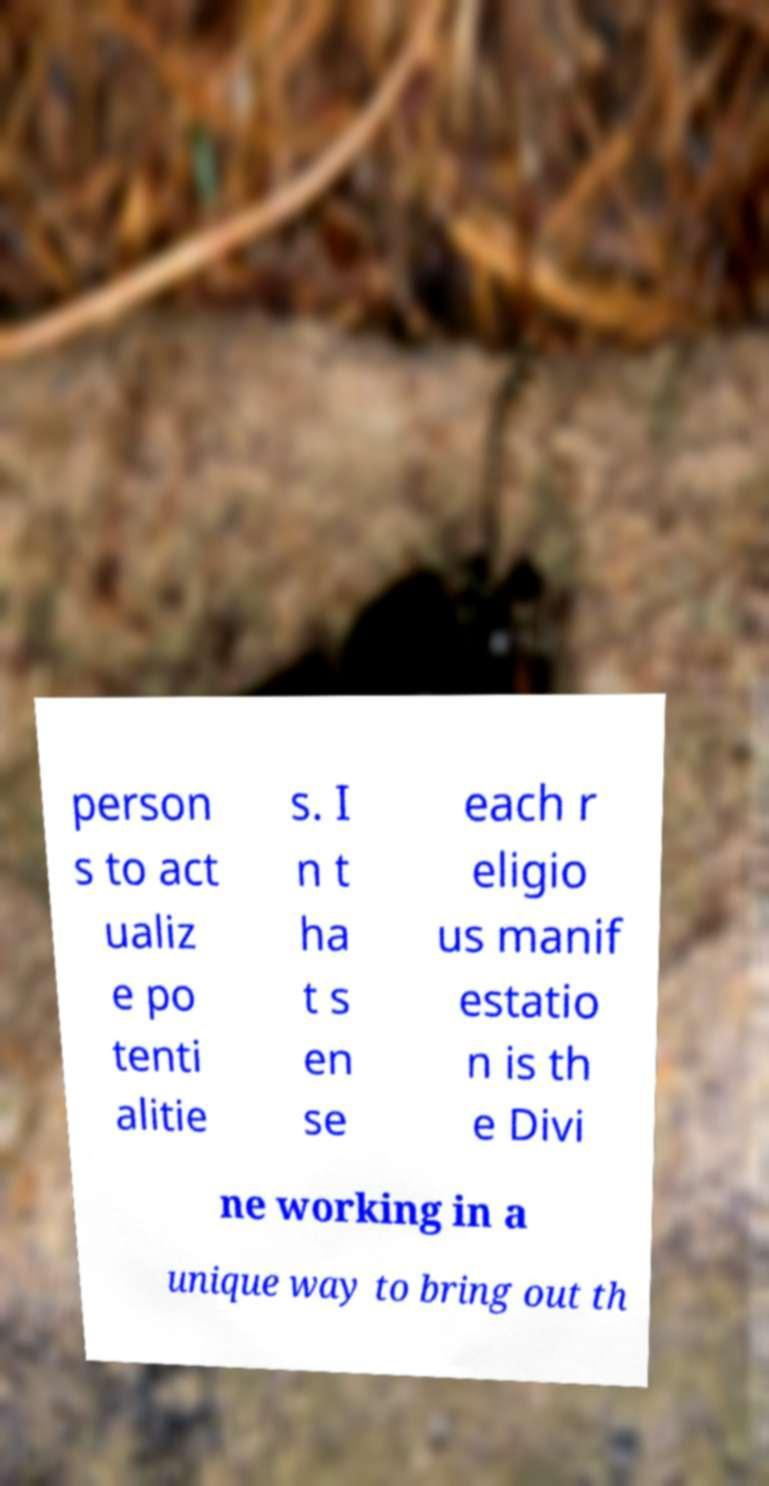I need the written content from this picture converted into text. Can you do that? person s to act ualiz e po tenti alitie s. I n t ha t s en se each r eligio us manif estatio n is th e Divi ne working in a unique way to bring out th 